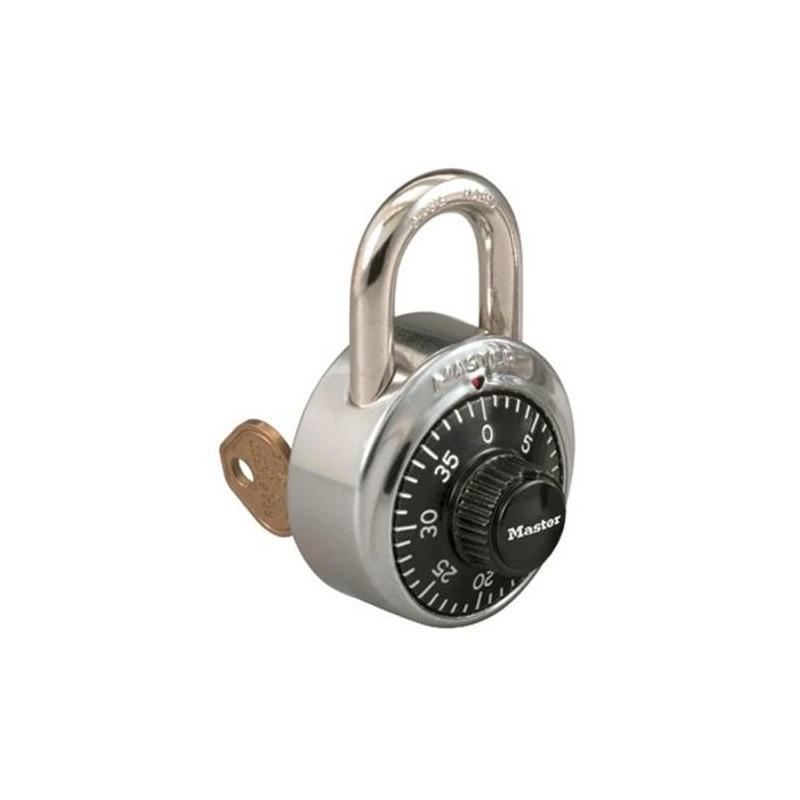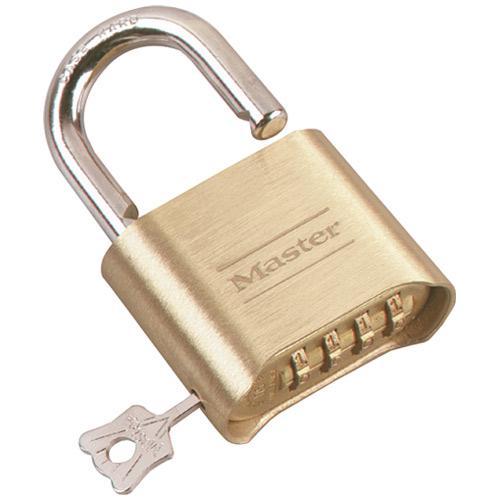The first image is the image on the left, the second image is the image on the right. For the images shown, is this caption "A lock in one image is round with a front dial and optional key, while a second image shows at least one padlock with number belts that scroll." true? Answer yes or no. Yes. The first image is the image on the left, the second image is the image on the right. Considering the images on both sides, is "An image shows a round lock with a key next to it, but not inserted in it." valid? Answer yes or no. No. 